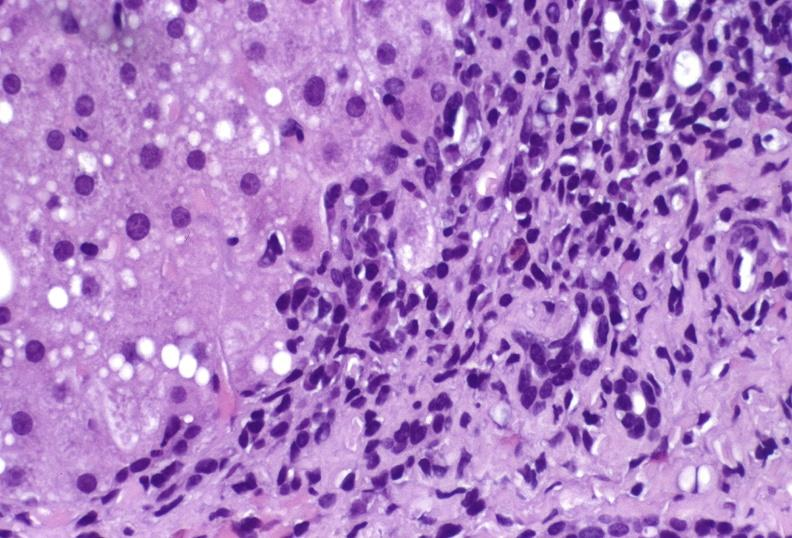what does this image show?
Answer the question using a single word or phrase. Hepatitis c virus 